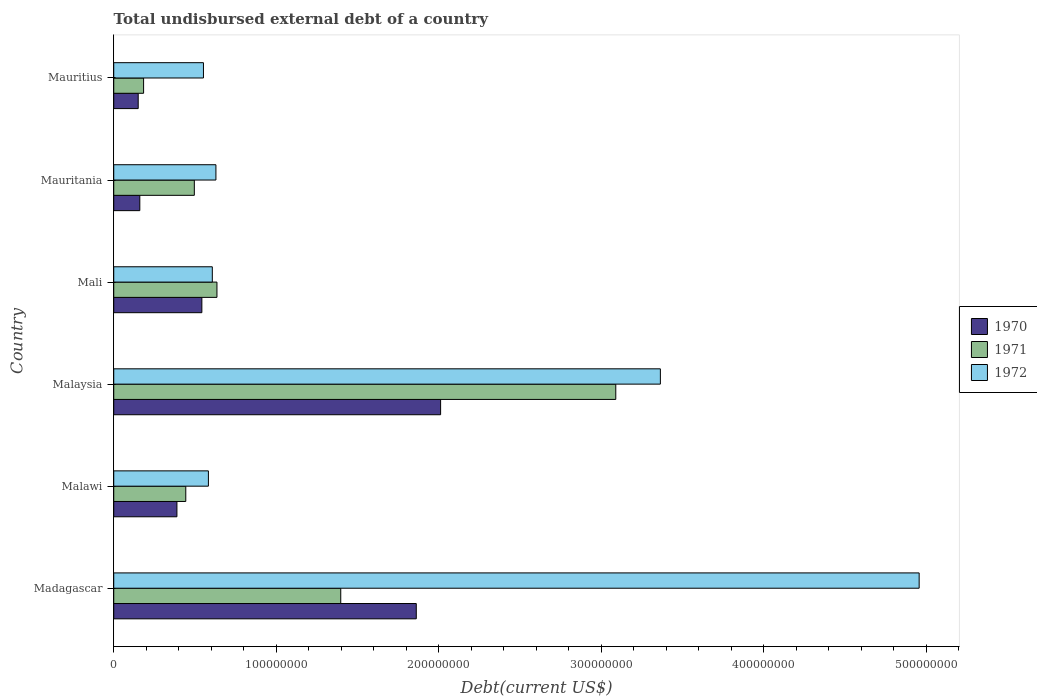How many bars are there on the 4th tick from the top?
Ensure brevity in your answer.  3. How many bars are there on the 1st tick from the bottom?
Provide a succinct answer. 3. What is the label of the 1st group of bars from the top?
Make the answer very short. Mauritius. What is the total undisbursed external debt in 1971 in Mauritius?
Your answer should be compact. 1.84e+07. Across all countries, what is the maximum total undisbursed external debt in 1971?
Keep it short and to the point. 3.09e+08. Across all countries, what is the minimum total undisbursed external debt in 1971?
Give a very brief answer. 1.84e+07. In which country was the total undisbursed external debt in 1971 maximum?
Offer a terse response. Malaysia. In which country was the total undisbursed external debt in 1972 minimum?
Your answer should be very brief. Mauritius. What is the total total undisbursed external debt in 1972 in the graph?
Make the answer very short. 1.07e+09. What is the difference between the total undisbursed external debt in 1972 in Malaysia and that in Mali?
Your answer should be very brief. 2.76e+08. What is the difference between the total undisbursed external debt in 1970 in Malawi and the total undisbursed external debt in 1972 in Malaysia?
Your answer should be compact. -2.98e+08. What is the average total undisbursed external debt in 1971 per country?
Provide a succinct answer. 1.04e+08. What is the difference between the total undisbursed external debt in 1972 and total undisbursed external debt in 1971 in Mali?
Ensure brevity in your answer.  -2.86e+06. In how many countries, is the total undisbursed external debt in 1971 greater than 220000000 US$?
Keep it short and to the point. 1. What is the ratio of the total undisbursed external debt in 1970 in Mali to that in Mauritius?
Your answer should be compact. 3.6. Is the total undisbursed external debt in 1972 in Malawi less than that in Mali?
Provide a succinct answer. Yes. Is the difference between the total undisbursed external debt in 1972 in Madagascar and Malaysia greater than the difference between the total undisbursed external debt in 1971 in Madagascar and Malaysia?
Make the answer very short. Yes. What is the difference between the highest and the second highest total undisbursed external debt in 1972?
Make the answer very short. 1.59e+08. What is the difference between the highest and the lowest total undisbursed external debt in 1972?
Ensure brevity in your answer.  4.40e+08. In how many countries, is the total undisbursed external debt in 1970 greater than the average total undisbursed external debt in 1970 taken over all countries?
Ensure brevity in your answer.  2. Is the sum of the total undisbursed external debt in 1970 in Malawi and Malaysia greater than the maximum total undisbursed external debt in 1971 across all countries?
Your answer should be very brief. No. Is it the case that in every country, the sum of the total undisbursed external debt in 1970 and total undisbursed external debt in 1971 is greater than the total undisbursed external debt in 1972?
Your answer should be compact. No. Are all the bars in the graph horizontal?
Offer a very short reply. Yes. How many countries are there in the graph?
Your answer should be very brief. 6. What is the difference between two consecutive major ticks on the X-axis?
Offer a terse response. 1.00e+08. Where does the legend appear in the graph?
Your answer should be compact. Center right. How many legend labels are there?
Give a very brief answer. 3. How are the legend labels stacked?
Provide a short and direct response. Vertical. What is the title of the graph?
Offer a terse response. Total undisbursed external debt of a country. Does "1995" appear as one of the legend labels in the graph?
Provide a succinct answer. No. What is the label or title of the X-axis?
Make the answer very short. Debt(current US$). What is the label or title of the Y-axis?
Provide a succinct answer. Country. What is the Debt(current US$) in 1970 in Madagascar?
Your response must be concise. 1.86e+08. What is the Debt(current US$) in 1971 in Madagascar?
Make the answer very short. 1.40e+08. What is the Debt(current US$) in 1972 in Madagascar?
Ensure brevity in your answer.  4.96e+08. What is the Debt(current US$) of 1970 in Malawi?
Your response must be concise. 3.89e+07. What is the Debt(current US$) of 1971 in Malawi?
Keep it short and to the point. 4.43e+07. What is the Debt(current US$) in 1972 in Malawi?
Keep it short and to the point. 5.83e+07. What is the Debt(current US$) of 1970 in Malaysia?
Provide a succinct answer. 2.01e+08. What is the Debt(current US$) of 1971 in Malaysia?
Provide a short and direct response. 3.09e+08. What is the Debt(current US$) in 1972 in Malaysia?
Keep it short and to the point. 3.36e+08. What is the Debt(current US$) in 1970 in Mali?
Ensure brevity in your answer.  5.42e+07. What is the Debt(current US$) in 1971 in Mali?
Provide a succinct answer. 6.35e+07. What is the Debt(current US$) of 1972 in Mali?
Ensure brevity in your answer.  6.07e+07. What is the Debt(current US$) of 1970 in Mauritania?
Your answer should be compact. 1.60e+07. What is the Debt(current US$) of 1971 in Mauritania?
Keep it short and to the point. 4.96e+07. What is the Debt(current US$) in 1972 in Mauritania?
Your response must be concise. 6.29e+07. What is the Debt(current US$) in 1970 in Mauritius?
Keep it short and to the point. 1.50e+07. What is the Debt(current US$) of 1971 in Mauritius?
Offer a very short reply. 1.84e+07. What is the Debt(current US$) of 1972 in Mauritius?
Offer a terse response. 5.52e+07. Across all countries, what is the maximum Debt(current US$) of 1970?
Give a very brief answer. 2.01e+08. Across all countries, what is the maximum Debt(current US$) of 1971?
Provide a succinct answer. 3.09e+08. Across all countries, what is the maximum Debt(current US$) of 1972?
Make the answer very short. 4.96e+08. Across all countries, what is the minimum Debt(current US$) in 1970?
Offer a terse response. 1.50e+07. Across all countries, what is the minimum Debt(current US$) of 1971?
Your answer should be compact. 1.84e+07. Across all countries, what is the minimum Debt(current US$) in 1972?
Your answer should be very brief. 5.52e+07. What is the total Debt(current US$) in 1970 in the graph?
Your answer should be compact. 5.12e+08. What is the total Debt(current US$) in 1971 in the graph?
Keep it short and to the point. 6.24e+08. What is the total Debt(current US$) in 1972 in the graph?
Your answer should be very brief. 1.07e+09. What is the difference between the Debt(current US$) in 1970 in Madagascar and that in Malawi?
Your response must be concise. 1.47e+08. What is the difference between the Debt(current US$) in 1971 in Madagascar and that in Malawi?
Your answer should be very brief. 9.54e+07. What is the difference between the Debt(current US$) of 1972 in Madagascar and that in Malawi?
Give a very brief answer. 4.37e+08. What is the difference between the Debt(current US$) of 1970 in Madagascar and that in Malaysia?
Keep it short and to the point. -1.50e+07. What is the difference between the Debt(current US$) of 1971 in Madagascar and that in Malaysia?
Give a very brief answer. -1.69e+08. What is the difference between the Debt(current US$) in 1972 in Madagascar and that in Malaysia?
Provide a short and direct response. 1.59e+08. What is the difference between the Debt(current US$) in 1970 in Madagascar and that in Mali?
Provide a succinct answer. 1.32e+08. What is the difference between the Debt(current US$) of 1971 in Madagascar and that in Mali?
Your answer should be compact. 7.62e+07. What is the difference between the Debt(current US$) of 1972 in Madagascar and that in Mali?
Make the answer very short. 4.35e+08. What is the difference between the Debt(current US$) of 1970 in Madagascar and that in Mauritania?
Offer a terse response. 1.70e+08. What is the difference between the Debt(current US$) of 1971 in Madagascar and that in Mauritania?
Make the answer very short. 9.01e+07. What is the difference between the Debt(current US$) of 1972 in Madagascar and that in Mauritania?
Give a very brief answer. 4.33e+08. What is the difference between the Debt(current US$) in 1970 in Madagascar and that in Mauritius?
Your answer should be compact. 1.71e+08. What is the difference between the Debt(current US$) in 1971 in Madagascar and that in Mauritius?
Ensure brevity in your answer.  1.21e+08. What is the difference between the Debt(current US$) of 1972 in Madagascar and that in Mauritius?
Keep it short and to the point. 4.40e+08. What is the difference between the Debt(current US$) in 1970 in Malawi and that in Malaysia?
Offer a terse response. -1.62e+08. What is the difference between the Debt(current US$) of 1971 in Malawi and that in Malaysia?
Provide a succinct answer. -2.65e+08. What is the difference between the Debt(current US$) in 1972 in Malawi and that in Malaysia?
Make the answer very short. -2.78e+08. What is the difference between the Debt(current US$) of 1970 in Malawi and that in Mali?
Keep it short and to the point. -1.53e+07. What is the difference between the Debt(current US$) in 1971 in Malawi and that in Mali?
Ensure brevity in your answer.  -1.92e+07. What is the difference between the Debt(current US$) of 1972 in Malawi and that in Mali?
Ensure brevity in your answer.  -2.41e+06. What is the difference between the Debt(current US$) of 1970 in Malawi and that in Mauritania?
Your answer should be very brief. 2.28e+07. What is the difference between the Debt(current US$) in 1971 in Malawi and that in Mauritania?
Offer a very short reply. -5.26e+06. What is the difference between the Debt(current US$) in 1972 in Malawi and that in Mauritania?
Your answer should be very brief. -4.63e+06. What is the difference between the Debt(current US$) of 1970 in Malawi and that in Mauritius?
Your answer should be compact. 2.38e+07. What is the difference between the Debt(current US$) in 1971 in Malawi and that in Mauritius?
Provide a succinct answer. 2.60e+07. What is the difference between the Debt(current US$) in 1972 in Malawi and that in Mauritius?
Your response must be concise. 3.05e+06. What is the difference between the Debt(current US$) in 1970 in Malaysia and that in Mali?
Keep it short and to the point. 1.47e+08. What is the difference between the Debt(current US$) of 1971 in Malaysia and that in Mali?
Provide a succinct answer. 2.45e+08. What is the difference between the Debt(current US$) in 1972 in Malaysia and that in Mali?
Your response must be concise. 2.76e+08. What is the difference between the Debt(current US$) in 1970 in Malaysia and that in Mauritania?
Keep it short and to the point. 1.85e+08. What is the difference between the Debt(current US$) of 1971 in Malaysia and that in Mauritania?
Offer a very short reply. 2.59e+08. What is the difference between the Debt(current US$) of 1972 in Malaysia and that in Mauritania?
Provide a succinct answer. 2.74e+08. What is the difference between the Debt(current US$) in 1970 in Malaysia and that in Mauritius?
Keep it short and to the point. 1.86e+08. What is the difference between the Debt(current US$) of 1971 in Malaysia and that in Mauritius?
Keep it short and to the point. 2.91e+08. What is the difference between the Debt(current US$) in 1972 in Malaysia and that in Mauritius?
Make the answer very short. 2.81e+08. What is the difference between the Debt(current US$) of 1970 in Mali and that in Mauritania?
Make the answer very short. 3.82e+07. What is the difference between the Debt(current US$) of 1971 in Mali and that in Mauritania?
Make the answer very short. 1.39e+07. What is the difference between the Debt(current US$) in 1972 in Mali and that in Mauritania?
Give a very brief answer. -2.22e+06. What is the difference between the Debt(current US$) in 1970 in Mali and that in Mauritius?
Provide a short and direct response. 3.92e+07. What is the difference between the Debt(current US$) in 1971 in Mali and that in Mauritius?
Offer a terse response. 4.51e+07. What is the difference between the Debt(current US$) of 1972 in Mali and that in Mauritius?
Ensure brevity in your answer.  5.45e+06. What is the difference between the Debt(current US$) in 1970 in Mauritania and that in Mauritius?
Provide a short and direct response. 9.95e+05. What is the difference between the Debt(current US$) of 1971 in Mauritania and that in Mauritius?
Provide a short and direct response. 3.12e+07. What is the difference between the Debt(current US$) in 1972 in Mauritania and that in Mauritius?
Your response must be concise. 7.67e+06. What is the difference between the Debt(current US$) in 1970 in Madagascar and the Debt(current US$) in 1971 in Malawi?
Your response must be concise. 1.42e+08. What is the difference between the Debt(current US$) in 1970 in Madagascar and the Debt(current US$) in 1972 in Malawi?
Your answer should be very brief. 1.28e+08. What is the difference between the Debt(current US$) of 1971 in Madagascar and the Debt(current US$) of 1972 in Malawi?
Your answer should be compact. 8.14e+07. What is the difference between the Debt(current US$) in 1970 in Madagascar and the Debt(current US$) in 1971 in Malaysia?
Make the answer very short. -1.23e+08. What is the difference between the Debt(current US$) of 1970 in Madagascar and the Debt(current US$) of 1972 in Malaysia?
Your answer should be very brief. -1.50e+08. What is the difference between the Debt(current US$) of 1971 in Madagascar and the Debt(current US$) of 1972 in Malaysia?
Ensure brevity in your answer.  -1.97e+08. What is the difference between the Debt(current US$) in 1970 in Madagascar and the Debt(current US$) in 1971 in Mali?
Offer a very short reply. 1.23e+08. What is the difference between the Debt(current US$) in 1970 in Madagascar and the Debt(current US$) in 1972 in Mali?
Provide a succinct answer. 1.26e+08. What is the difference between the Debt(current US$) of 1971 in Madagascar and the Debt(current US$) of 1972 in Mali?
Your answer should be very brief. 7.90e+07. What is the difference between the Debt(current US$) of 1970 in Madagascar and the Debt(current US$) of 1971 in Mauritania?
Offer a terse response. 1.37e+08. What is the difference between the Debt(current US$) in 1970 in Madagascar and the Debt(current US$) in 1972 in Mauritania?
Give a very brief answer. 1.23e+08. What is the difference between the Debt(current US$) in 1971 in Madagascar and the Debt(current US$) in 1972 in Mauritania?
Your answer should be compact. 7.68e+07. What is the difference between the Debt(current US$) of 1970 in Madagascar and the Debt(current US$) of 1971 in Mauritius?
Make the answer very short. 1.68e+08. What is the difference between the Debt(current US$) in 1970 in Madagascar and the Debt(current US$) in 1972 in Mauritius?
Your answer should be compact. 1.31e+08. What is the difference between the Debt(current US$) in 1971 in Madagascar and the Debt(current US$) in 1972 in Mauritius?
Your answer should be compact. 8.45e+07. What is the difference between the Debt(current US$) of 1970 in Malawi and the Debt(current US$) of 1971 in Malaysia?
Offer a terse response. -2.70e+08. What is the difference between the Debt(current US$) in 1970 in Malawi and the Debt(current US$) in 1972 in Malaysia?
Provide a succinct answer. -2.98e+08. What is the difference between the Debt(current US$) in 1971 in Malawi and the Debt(current US$) in 1972 in Malaysia?
Your answer should be compact. -2.92e+08. What is the difference between the Debt(current US$) in 1970 in Malawi and the Debt(current US$) in 1971 in Mali?
Give a very brief answer. -2.46e+07. What is the difference between the Debt(current US$) in 1970 in Malawi and the Debt(current US$) in 1972 in Mali?
Offer a very short reply. -2.18e+07. What is the difference between the Debt(current US$) of 1971 in Malawi and the Debt(current US$) of 1972 in Mali?
Provide a short and direct response. -1.63e+07. What is the difference between the Debt(current US$) of 1970 in Malawi and the Debt(current US$) of 1971 in Mauritania?
Offer a terse response. -1.07e+07. What is the difference between the Debt(current US$) of 1970 in Malawi and the Debt(current US$) of 1972 in Mauritania?
Offer a terse response. -2.40e+07. What is the difference between the Debt(current US$) in 1971 in Malawi and the Debt(current US$) in 1972 in Mauritania?
Keep it short and to the point. -1.86e+07. What is the difference between the Debt(current US$) in 1970 in Malawi and the Debt(current US$) in 1971 in Mauritius?
Give a very brief answer. 2.05e+07. What is the difference between the Debt(current US$) of 1970 in Malawi and the Debt(current US$) of 1972 in Mauritius?
Ensure brevity in your answer.  -1.63e+07. What is the difference between the Debt(current US$) of 1971 in Malawi and the Debt(current US$) of 1972 in Mauritius?
Your response must be concise. -1.09e+07. What is the difference between the Debt(current US$) of 1970 in Malaysia and the Debt(current US$) of 1971 in Mali?
Your response must be concise. 1.38e+08. What is the difference between the Debt(current US$) in 1970 in Malaysia and the Debt(current US$) in 1972 in Mali?
Provide a short and direct response. 1.40e+08. What is the difference between the Debt(current US$) of 1971 in Malaysia and the Debt(current US$) of 1972 in Mali?
Your answer should be compact. 2.48e+08. What is the difference between the Debt(current US$) in 1970 in Malaysia and the Debt(current US$) in 1971 in Mauritania?
Your response must be concise. 1.52e+08. What is the difference between the Debt(current US$) of 1970 in Malaysia and the Debt(current US$) of 1972 in Mauritania?
Offer a very short reply. 1.38e+08. What is the difference between the Debt(current US$) of 1971 in Malaysia and the Debt(current US$) of 1972 in Mauritania?
Offer a terse response. 2.46e+08. What is the difference between the Debt(current US$) in 1970 in Malaysia and the Debt(current US$) in 1971 in Mauritius?
Your answer should be compact. 1.83e+08. What is the difference between the Debt(current US$) of 1970 in Malaysia and the Debt(current US$) of 1972 in Mauritius?
Make the answer very short. 1.46e+08. What is the difference between the Debt(current US$) of 1971 in Malaysia and the Debt(current US$) of 1972 in Mauritius?
Offer a very short reply. 2.54e+08. What is the difference between the Debt(current US$) of 1970 in Mali and the Debt(current US$) of 1971 in Mauritania?
Keep it short and to the point. 4.64e+06. What is the difference between the Debt(current US$) of 1970 in Mali and the Debt(current US$) of 1972 in Mauritania?
Keep it short and to the point. -8.65e+06. What is the difference between the Debt(current US$) in 1971 in Mali and the Debt(current US$) in 1972 in Mauritania?
Your answer should be very brief. 6.38e+05. What is the difference between the Debt(current US$) in 1970 in Mali and the Debt(current US$) in 1971 in Mauritius?
Provide a succinct answer. 3.59e+07. What is the difference between the Debt(current US$) in 1970 in Mali and the Debt(current US$) in 1972 in Mauritius?
Your answer should be compact. -9.81e+05. What is the difference between the Debt(current US$) in 1971 in Mali and the Debt(current US$) in 1972 in Mauritius?
Keep it short and to the point. 8.31e+06. What is the difference between the Debt(current US$) of 1970 in Mauritania and the Debt(current US$) of 1971 in Mauritius?
Make the answer very short. -2.33e+06. What is the difference between the Debt(current US$) in 1970 in Mauritania and the Debt(current US$) in 1972 in Mauritius?
Offer a very short reply. -3.92e+07. What is the difference between the Debt(current US$) in 1971 in Mauritania and the Debt(current US$) in 1972 in Mauritius?
Your response must be concise. -5.62e+06. What is the average Debt(current US$) in 1970 per country?
Your answer should be compact. 8.53e+07. What is the average Debt(current US$) in 1971 per country?
Keep it short and to the point. 1.04e+08. What is the average Debt(current US$) in 1972 per country?
Ensure brevity in your answer.  1.78e+08. What is the difference between the Debt(current US$) in 1970 and Debt(current US$) in 1971 in Madagascar?
Make the answer very short. 4.65e+07. What is the difference between the Debt(current US$) in 1970 and Debt(current US$) in 1972 in Madagascar?
Your answer should be very brief. -3.09e+08. What is the difference between the Debt(current US$) of 1971 and Debt(current US$) of 1972 in Madagascar?
Give a very brief answer. -3.56e+08. What is the difference between the Debt(current US$) of 1970 and Debt(current US$) of 1971 in Malawi?
Ensure brevity in your answer.  -5.45e+06. What is the difference between the Debt(current US$) of 1970 and Debt(current US$) of 1972 in Malawi?
Provide a succinct answer. -1.94e+07. What is the difference between the Debt(current US$) of 1971 and Debt(current US$) of 1972 in Malawi?
Your response must be concise. -1.39e+07. What is the difference between the Debt(current US$) of 1970 and Debt(current US$) of 1971 in Malaysia?
Your response must be concise. -1.08e+08. What is the difference between the Debt(current US$) in 1970 and Debt(current US$) in 1972 in Malaysia?
Offer a terse response. -1.35e+08. What is the difference between the Debt(current US$) in 1971 and Debt(current US$) in 1972 in Malaysia?
Give a very brief answer. -2.74e+07. What is the difference between the Debt(current US$) in 1970 and Debt(current US$) in 1971 in Mali?
Your response must be concise. -9.29e+06. What is the difference between the Debt(current US$) in 1970 and Debt(current US$) in 1972 in Mali?
Your answer should be very brief. -6.43e+06. What is the difference between the Debt(current US$) of 1971 and Debt(current US$) of 1972 in Mali?
Ensure brevity in your answer.  2.86e+06. What is the difference between the Debt(current US$) of 1970 and Debt(current US$) of 1971 in Mauritania?
Make the answer very short. -3.35e+07. What is the difference between the Debt(current US$) in 1970 and Debt(current US$) in 1972 in Mauritania?
Offer a very short reply. -4.68e+07. What is the difference between the Debt(current US$) in 1971 and Debt(current US$) in 1972 in Mauritania?
Offer a terse response. -1.33e+07. What is the difference between the Debt(current US$) in 1970 and Debt(current US$) in 1971 in Mauritius?
Provide a succinct answer. -3.32e+06. What is the difference between the Debt(current US$) of 1970 and Debt(current US$) of 1972 in Mauritius?
Offer a very short reply. -4.02e+07. What is the difference between the Debt(current US$) of 1971 and Debt(current US$) of 1972 in Mauritius?
Offer a terse response. -3.68e+07. What is the ratio of the Debt(current US$) in 1970 in Madagascar to that in Malawi?
Offer a very short reply. 4.79. What is the ratio of the Debt(current US$) of 1971 in Madagascar to that in Malawi?
Your answer should be very brief. 3.15. What is the ratio of the Debt(current US$) of 1972 in Madagascar to that in Malawi?
Ensure brevity in your answer.  8.51. What is the ratio of the Debt(current US$) of 1970 in Madagascar to that in Malaysia?
Provide a short and direct response. 0.93. What is the ratio of the Debt(current US$) in 1971 in Madagascar to that in Malaysia?
Your answer should be very brief. 0.45. What is the ratio of the Debt(current US$) of 1972 in Madagascar to that in Malaysia?
Offer a very short reply. 1.47. What is the ratio of the Debt(current US$) of 1970 in Madagascar to that in Mali?
Make the answer very short. 3.43. What is the ratio of the Debt(current US$) in 1971 in Madagascar to that in Mali?
Offer a terse response. 2.2. What is the ratio of the Debt(current US$) of 1972 in Madagascar to that in Mali?
Provide a succinct answer. 8.17. What is the ratio of the Debt(current US$) of 1970 in Madagascar to that in Mauritania?
Your response must be concise. 11.6. What is the ratio of the Debt(current US$) of 1971 in Madagascar to that in Mauritania?
Give a very brief answer. 2.82. What is the ratio of the Debt(current US$) in 1972 in Madagascar to that in Mauritania?
Your response must be concise. 7.88. What is the ratio of the Debt(current US$) of 1970 in Madagascar to that in Mauritius?
Your answer should be very brief. 12.37. What is the ratio of the Debt(current US$) in 1971 in Madagascar to that in Mauritius?
Provide a succinct answer. 7.6. What is the ratio of the Debt(current US$) of 1972 in Madagascar to that in Mauritius?
Make the answer very short. 8.98. What is the ratio of the Debt(current US$) of 1970 in Malawi to that in Malaysia?
Your answer should be very brief. 0.19. What is the ratio of the Debt(current US$) in 1971 in Malawi to that in Malaysia?
Give a very brief answer. 0.14. What is the ratio of the Debt(current US$) in 1972 in Malawi to that in Malaysia?
Your answer should be compact. 0.17. What is the ratio of the Debt(current US$) in 1970 in Malawi to that in Mali?
Your response must be concise. 0.72. What is the ratio of the Debt(current US$) in 1971 in Malawi to that in Mali?
Keep it short and to the point. 0.7. What is the ratio of the Debt(current US$) in 1972 in Malawi to that in Mali?
Offer a terse response. 0.96. What is the ratio of the Debt(current US$) of 1970 in Malawi to that in Mauritania?
Provide a short and direct response. 2.42. What is the ratio of the Debt(current US$) of 1971 in Malawi to that in Mauritania?
Make the answer very short. 0.89. What is the ratio of the Debt(current US$) in 1972 in Malawi to that in Mauritania?
Give a very brief answer. 0.93. What is the ratio of the Debt(current US$) of 1970 in Malawi to that in Mauritius?
Ensure brevity in your answer.  2.58. What is the ratio of the Debt(current US$) in 1971 in Malawi to that in Mauritius?
Your answer should be very brief. 2.41. What is the ratio of the Debt(current US$) in 1972 in Malawi to that in Mauritius?
Your answer should be compact. 1.06. What is the ratio of the Debt(current US$) of 1970 in Malaysia to that in Mali?
Make the answer very short. 3.71. What is the ratio of the Debt(current US$) in 1971 in Malaysia to that in Mali?
Your answer should be very brief. 4.86. What is the ratio of the Debt(current US$) in 1972 in Malaysia to that in Mali?
Ensure brevity in your answer.  5.55. What is the ratio of the Debt(current US$) of 1970 in Malaysia to that in Mauritania?
Make the answer very short. 12.54. What is the ratio of the Debt(current US$) in 1971 in Malaysia to that in Mauritania?
Provide a succinct answer. 6.23. What is the ratio of the Debt(current US$) of 1972 in Malaysia to that in Mauritania?
Provide a succinct answer. 5.35. What is the ratio of the Debt(current US$) in 1970 in Malaysia to that in Mauritius?
Give a very brief answer. 13.37. What is the ratio of the Debt(current US$) of 1971 in Malaysia to that in Mauritius?
Keep it short and to the point. 16.82. What is the ratio of the Debt(current US$) in 1972 in Malaysia to that in Mauritius?
Your answer should be very brief. 6.09. What is the ratio of the Debt(current US$) of 1970 in Mali to that in Mauritania?
Make the answer very short. 3.38. What is the ratio of the Debt(current US$) of 1971 in Mali to that in Mauritania?
Offer a terse response. 1.28. What is the ratio of the Debt(current US$) of 1972 in Mali to that in Mauritania?
Offer a terse response. 0.96. What is the ratio of the Debt(current US$) in 1970 in Mali to that in Mauritius?
Offer a terse response. 3.6. What is the ratio of the Debt(current US$) of 1971 in Mali to that in Mauritius?
Ensure brevity in your answer.  3.46. What is the ratio of the Debt(current US$) of 1972 in Mali to that in Mauritius?
Your answer should be compact. 1.1. What is the ratio of the Debt(current US$) of 1970 in Mauritania to that in Mauritius?
Make the answer very short. 1.07. What is the ratio of the Debt(current US$) of 1971 in Mauritania to that in Mauritius?
Your answer should be compact. 2.7. What is the ratio of the Debt(current US$) of 1972 in Mauritania to that in Mauritius?
Your answer should be compact. 1.14. What is the difference between the highest and the second highest Debt(current US$) of 1970?
Provide a short and direct response. 1.50e+07. What is the difference between the highest and the second highest Debt(current US$) of 1971?
Give a very brief answer. 1.69e+08. What is the difference between the highest and the second highest Debt(current US$) in 1972?
Make the answer very short. 1.59e+08. What is the difference between the highest and the lowest Debt(current US$) of 1970?
Make the answer very short. 1.86e+08. What is the difference between the highest and the lowest Debt(current US$) of 1971?
Ensure brevity in your answer.  2.91e+08. What is the difference between the highest and the lowest Debt(current US$) in 1972?
Your answer should be compact. 4.40e+08. 